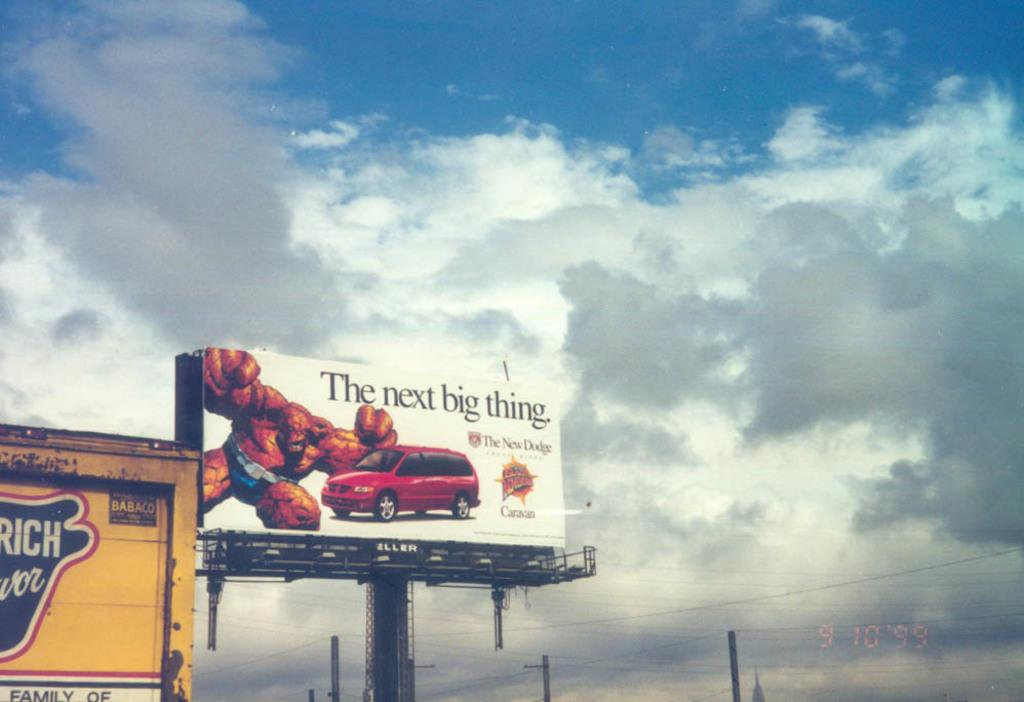<image>
Provide a brief description of the given image. A billboard of a comic book character jumping towards a car with the tagline "The next big thing." 